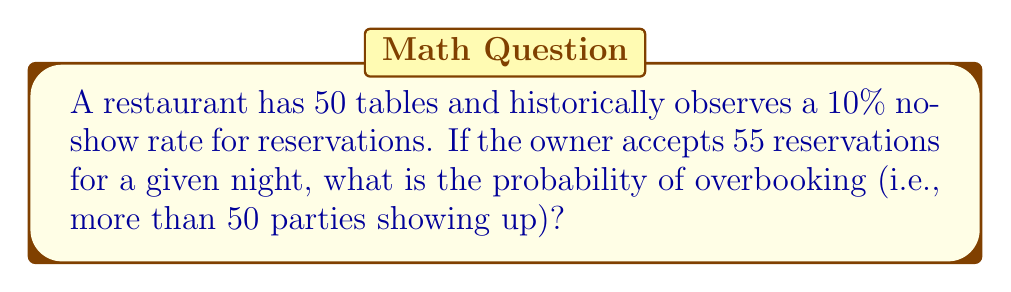What is the answer to this math problem? Let's approach this step-by-step using the binomial distribution:

1) Let $X$ be the number of parties that show up.

2) The probability of a party showing up is $p = 1 - 0.10 = 0.90$.

3) We have $n = 55$ reservations.

4) We want to find $P(X > 50)$, which is equivalent to $1 - P(X \leq 50)$.

5) $X$ follows a binomial distribution: $X \sim B(55, 0.90)$

6) We can calculate this using the cumulative binomial probability:

   $$P(X \leq 50) = \sum_{k=0}^{50} \binom{55}{k} (0.90)^k (0.10)^{55-k}$$

7) Using a calculator or statistical software (as this sum is complex to calculate by hand):

   $P(X \leq 50) \approx 0.2434$

8) Therefore, the probability of overbooking is:

   $$P(X > 50) = 1 - P(X \leq 50) = 1 - 0.2434 = 0.7566$$
Answer: 0.7566 or 75.66% 